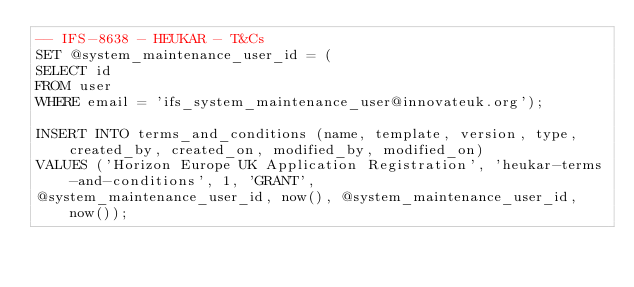<code> <loc_0><loc_0><loc_500><loc_500><_SQL_>-- IFS-8638 - HEUKAR - T&Cs
SET @system_maintenance_user_id = (
SELECT id
FROM user
WHERE email = 'ifs_system_maintenance_user@innovateuk.org');

INSERT INTO terms_and_conditions (name, template, version, type, created_by, created_on, modified_by, modified_on)
VALUES ('Horizon Europe UK Application Registration', 'heukar-terms-and-conditions', 1, 'GRANT',
@system_maintenance_user_id, now(), @system_maintenance_user_id, now());</code> 